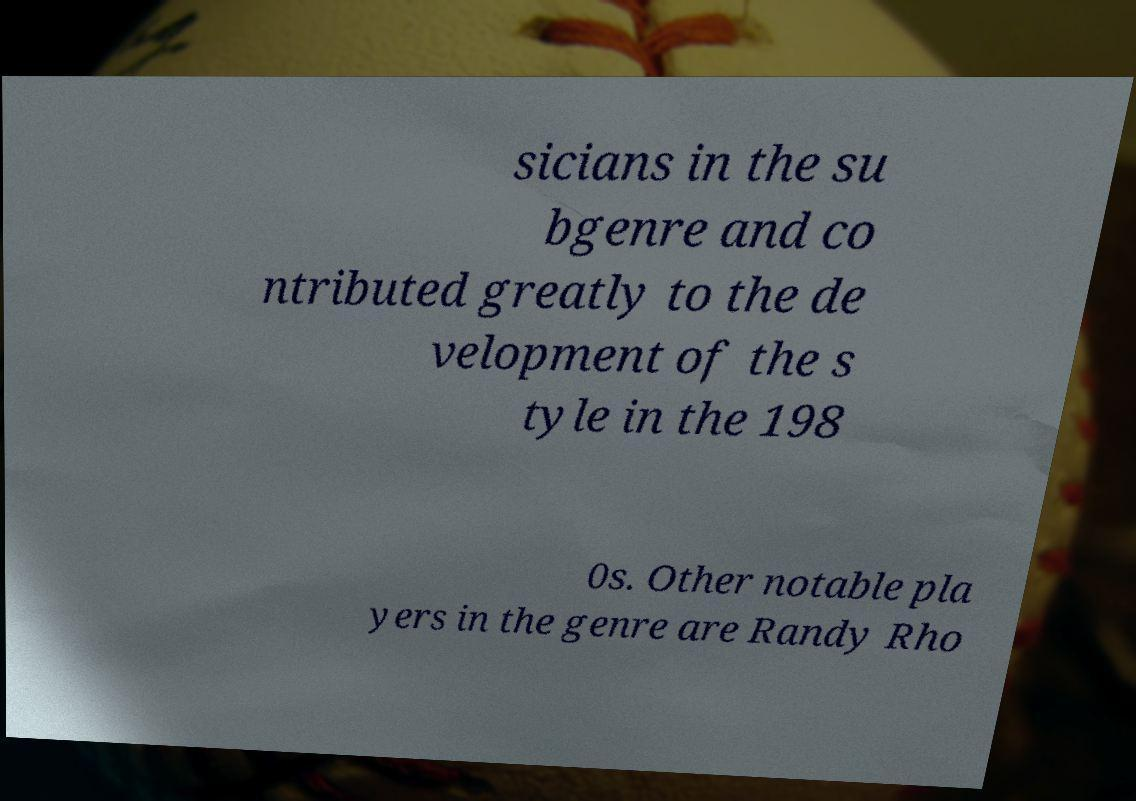Can you read and provide the text displayed in the image?This photo seems to have some interesting text. Can you extract and type it out for me? sicians in the su bgenre and co ntributed greatly to the de velopment of the s tyle in the 198 0s. Other notable pla yers in the genre are Randy Rho 